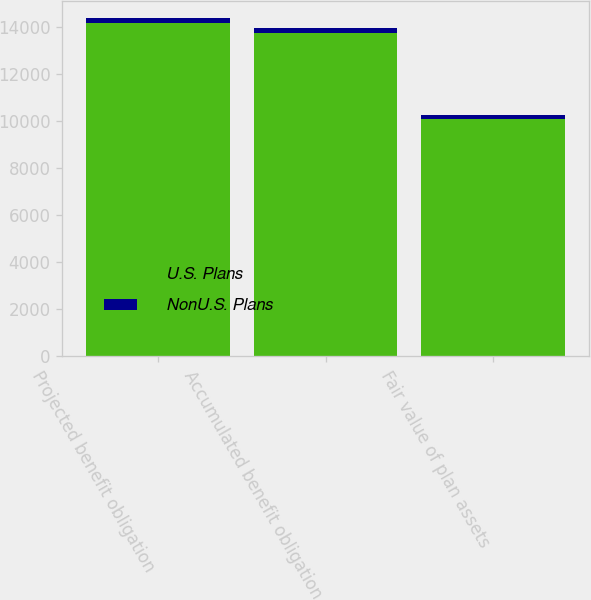<chart> <loc_0><loc_0><loc_500><loc_500><stacked_bar_chart><ecel><fcel>Projected benefit obligation<fcel>Accumulated benefit obligation<fcel>Fair value of plan assets<nl><fcel>U.S. Plans<fcel>14201<fcel>13772<fcel>10111<nl><fcel>NonU.S. Plans<fcel>200<fcel>188<fcel>143<nl></chart> 